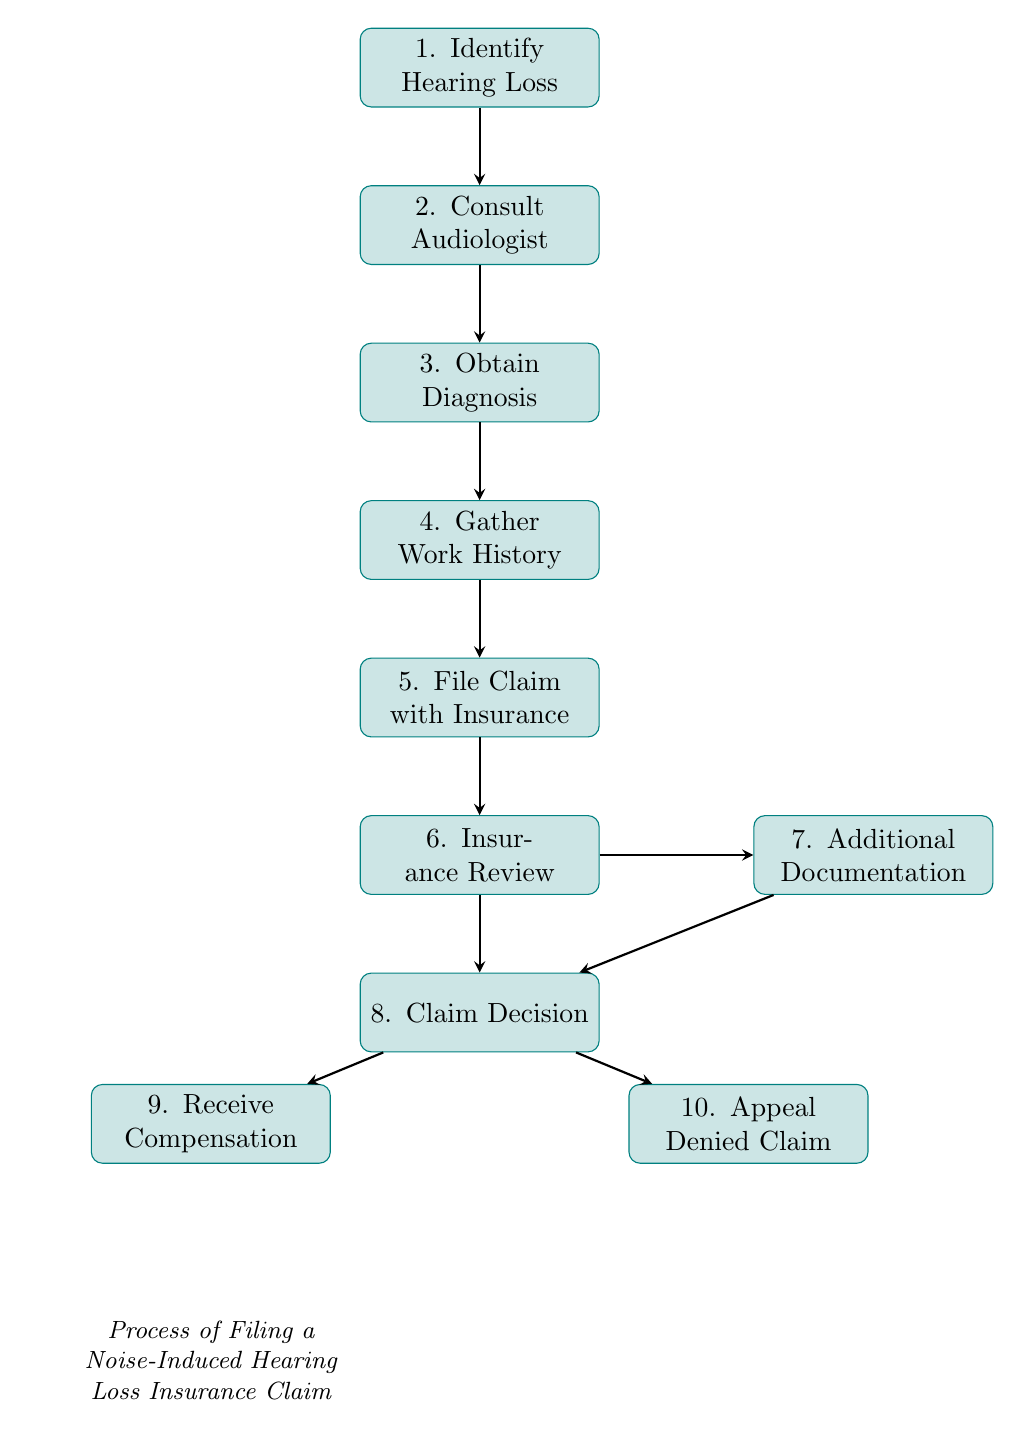What is the first step in the process? The diagram begins with the node labeled "Identify Hearing Loss," which is the first step indicated at the top of the flow chart.
Answer: Identify Hearing Loss How many steps are in the flowchart? The flowchart consists of 10 nodes, each representing a step in the claim process, which can be counted directly from the diagram.
Answer: 10 What follows after obtaining a diagnosis? After the step "Obtain Diagnosis," the diagram flows down to the next step labeled "Gather Work History," which directly follows it.
Answer: Gather Work History What is the outcome if the claim is approved? The flowchart specifies that if the claim is approved, the next step is "Receive Compensation," which clearly states the outcome in that case.
Answer: Receive Compensation If the insurance review requires more documentation, what is the next step? The diagram shows that if additional documentation is needed during the "Insurance Review," it proceeds to the "Additional Documentation" step for gathering more information.
Answer: Additional Documentation What happens after filing a claim with the insurance? Once a claim is filed with the insurance in the flowchart, the subsequent step is "Insurance Review," indicating the claim will be evaluated.
Answer: Insurance Review How does the flowchart represent the decision-making process? The diagram illustrates the decision-making process through the "Claim Decision" node, which branches into two outcomes: "Receive Compensation" for approval and "Appeal Denied Claim" for a denial. This indicates a clear decision checkpoint.
Answer: Claim Decision What documents need to be gathered for filing a claim? The diagram specifies that "Gather Work History" involves collecting documents detailing the exposure to loud noise, which is crucial for the claim process.
Answer: Work History What step should be taken if the claim is denied? According to the flowchart, if the claim is denied, the next course of action is to "Appeal Denied Claim," which outlines the option available for the claimant.
Answer: Appeal Denied Claim What is the role of the audiologist in this process? The "Consult Audiologist" step indicates the audiologist's role is to evaluate hearing loss and provide an official diagnosis, which is essential for subsequent steps in the claim process.
Answer: Consult Audiologist 